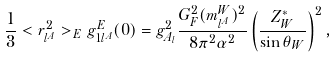Convert formula to latex. <formula><loc_0><loc_0><loc_500><loc_500>\frac { 1 } { 3 } < r ^ { 2 } _ { l ^ { A } } > _ { E } g _ { 1 l ^ { A } } ^ { E } ( 0 ) = g _ { A _ { l } } ^ { 2 } \frac { G _ { F } ^ { 2 } ( m _ { l ^ { A } } ^ { W } ) ^ { 2 } } { 8 \pi ^ { 2 } \alpha ^ { 2 } } \left ( \frac { Z _ { W } ^ { * } } { \sin \theta _ { W } } \right ) ^ { 2 } ,</formula> 